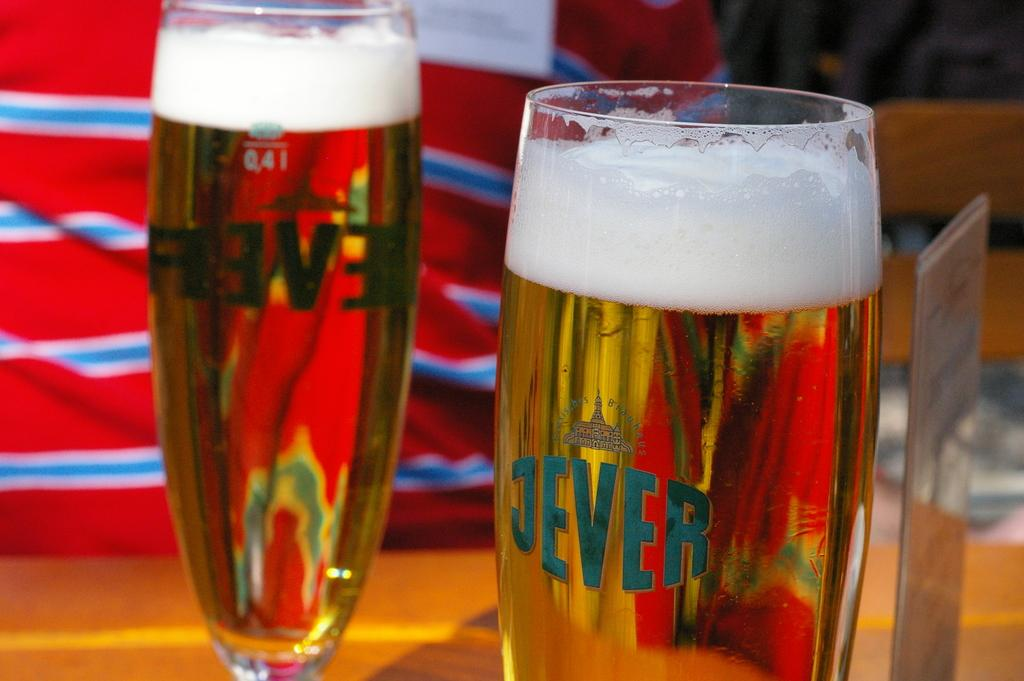<image>
Describe the image concisely. tow Jever champagne flutes are on the table 